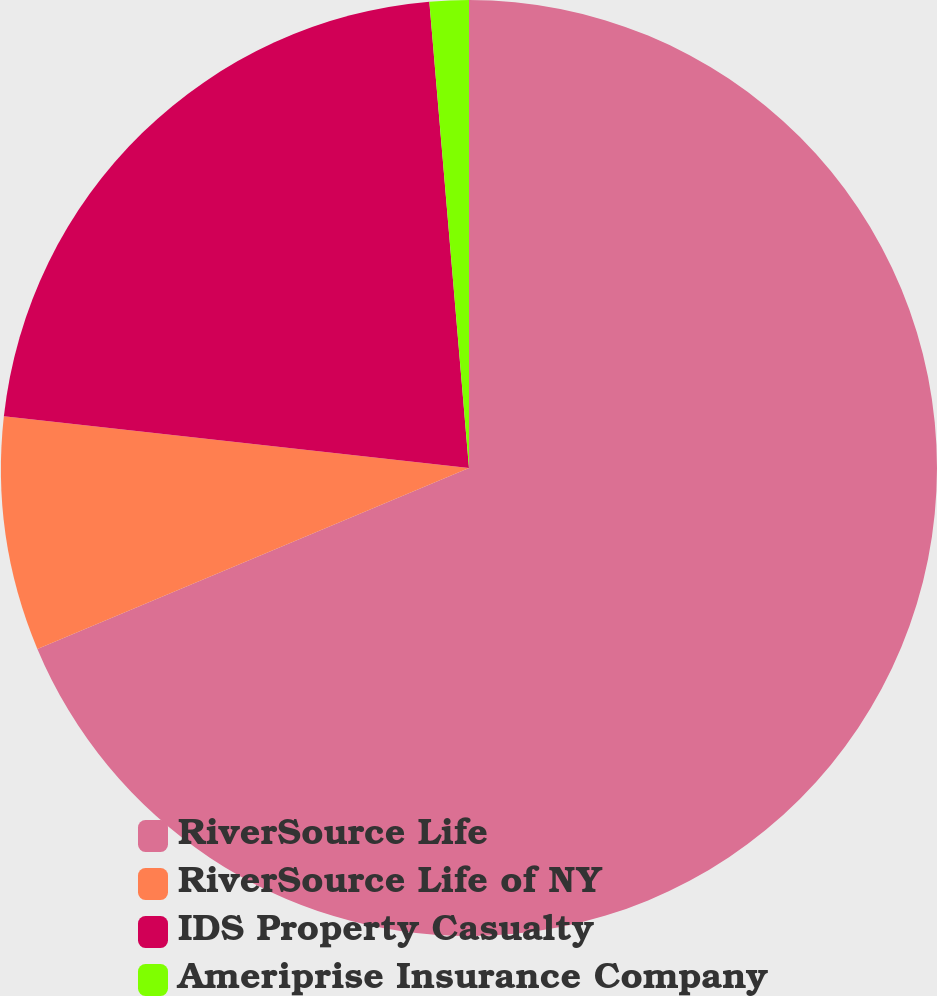<chart> <loc_0><loc_0><loc_500><loc_500><pie_chart><fcel>RiverSource Life<fcel>RiverSource Life of NY<fcel>IDS Property Casualty<fcel>Ameriprise Insurance Company<nl><fcel>68.69%<fcel>8.08%<fcel>21.89%<fcel>1.35%<nl></chart> 